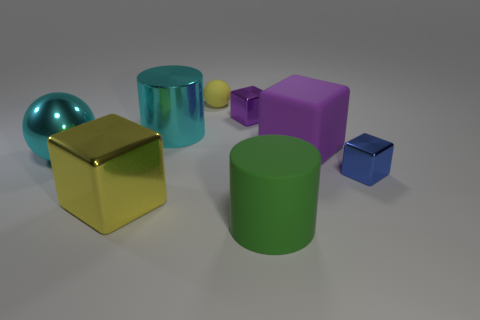There is a cyan thing that is left of the large cyan shiny cylinder; what material is it?
Offer a very short reply. Metal. Are there the same number of big green cylinders behind the blue block and large brown things?
Your response must be concise. Yes. What is the material of the tiny thing that is behind the shiny cube behind the shiny sphere?
Ensure brevity in your answer.  Rubber. What is the shape of the large thing that is both to the right of the yellow shiny thing and left of the small purple shiny object?
Provide a succinct answer. Cylinder. There is a blue thing that is the same shape as the tiny purple metallic object; what is its size?
Provide a succinct answer. Small. Is the number of large cyan metal cylinders behind the cyan shiny cylinder less than the number of rubber things?
Provide a short and direct response. Yes. How big is the cylinder that is on the right side of the cyan metal cylinder?
Offer a terse response. Large. What color is the large metal thing that is the same shape as the big purple rubber object?
Make the answer very short. Yellow. What number of large shiny spheres have the same color as the big metal cylinder?
Your answer should be very brief. 1. There is a cyan metallic object on the left side of the cube that is to the left of the big metal cylinder; are there any big shiny things right of it?
Ensure brevity in your answer.  Yes. 